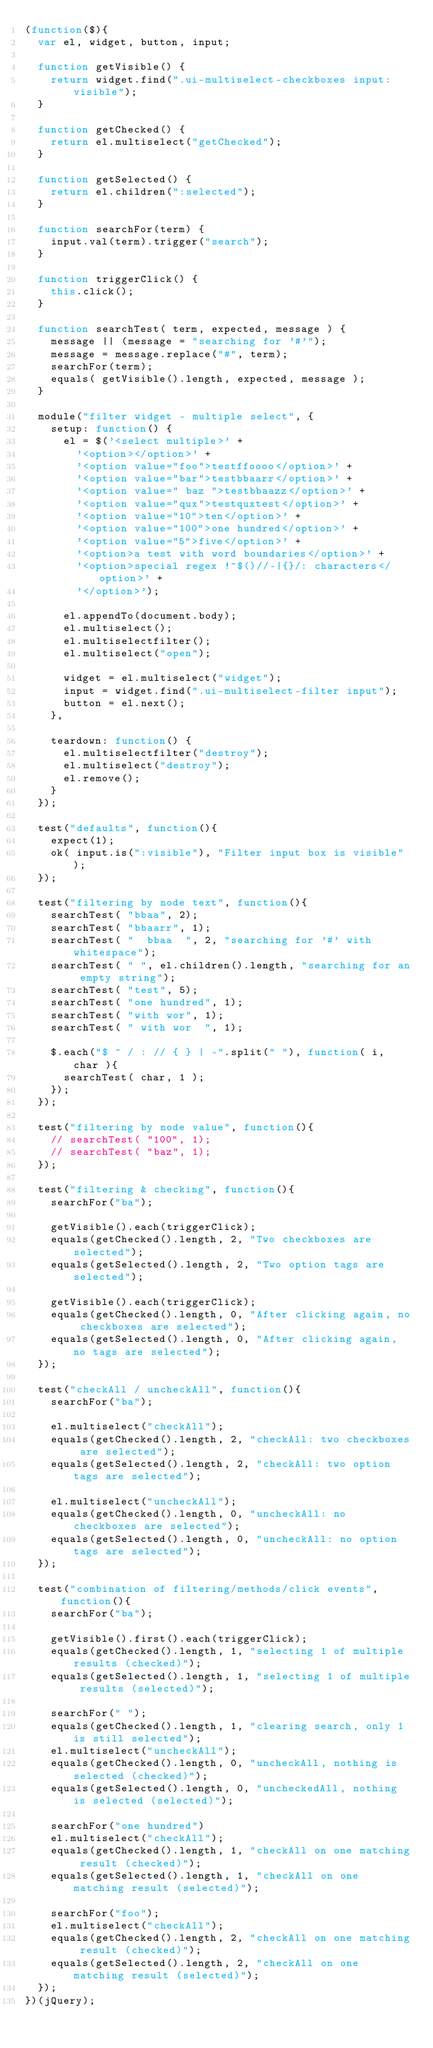<code> <loc_0><loc_0><loc_500><loc_500><_JavaScript_>(function($){
  var el, widget, button, input;

  function getVisible() {
    return widget.find(".ui-multiselect-checkboxes input:visible");
  }

  function getChecked() {
    return el.multiselect("getChecked");
  }

  function getSelected() {
    return el.children(":selected");
  }

  function searchFor(term) {
    input.val(term).trigger("search");
  }

  function triggerClick() {
    this.click();
  }

  function searchTest( term, expected, message ) {
    message || (message = "searching for '#'");
    message = message.replace("#", term);
    searchFor(term);
    equals( getVisible().length, expected, message );
  }

  module("filter widget - multiple select", {
    setup: function() {
      el = $('<select multiple>' +
        '<option></option>' +
        '<option value="foo">testffoooo</option>' +
        '<option value="bar">testbbaarr</option>' +
        '<option value=" baz ">testbbaazz</option>' +
        '<option value="qux">testquxtest</option>' +
        '<option value="10">ten</option>' +
        '<option value="100">one hundred</option>' +
        '<option value="5">five</option>' +
        '<option>a test with word boundaries</option>' +
        '<option>special regex !^$()//-|{}/: characters</option>' +
        '</option>');

      el.appendTo(document.body);
      el.multiselect();
      el.multiselectfilter();
      el.multiselect("open");

      widget = el.multiselect("widget");
      input = widget.find(".ui-multiselect-filter input");
      button = el.next();
    },

    teardown: function() {
      el.multiselectfilter("destroy");
      el.multiselect("destroy");
      el.remove();
    }
  });

  test("defaults", function(){
    expect(1);
    ok( input.is(":visible"), "Filter input box is visible" );
  });

  test("filtering by node text", function(){
    searchTest( "bbaa", 2);
    searchTest( "bbaarr", 1);
    searchTest( "  bbaa  ", 2, "searching for '#' with whitespace");
    searchTest( " ", el.children().length, "searching for an empty string");
    searchTest( "test", 5);
    searchTest( "one hundred", 1);
    searchTest( "with wor", 1);
    searchTest( " with wor  ", 1);

    $.each("$ ^ / : // { } | -".split(" "), function( i, char ){
      searchTest( char, 1 );
    });
  });

  test("filtering by node value", function(){
    // searchTest( "100", 1);
    // searchTest( "baz", 1);
  });

  test("filtering & checking", function(){
    searchFor("ba");

    getVisible().each(triggerClick);
    equals(getChecked().length, 2, "Two checkboxes are selected");
    equals(getSelected().length, 2, "Two option tags are selected");

    getVisible().each(triggerClick);
    equals(getChecked().length, 0, "After clicking again, no checkboxes are selected");
    equals(getSelected().length, 0, "After clicking again, no tags are selected");
  });

  test("checkAll / uncheckAll", function(){
    searchFor("ba");

    el.multiselect("checkAll");
    equals(getChecked().length, 2, "checkAll: two checkboxes are selected");
    equals(getSelected().length, 2, "checkAll: two option tags are selected");

    el.multiselect("uncheckAll");
    equals(getChecked().length, 0, "uncheckAll: no checkboxes are selected");
    equals(getSelected().length, 0, "uncheckAll: no option tags are selected");
  });

  test("combination of filtering/methods/click events", function(){
    searchFor("ba");

    getVisible().first().each(triggerClick);
    equals(getChecked().length, 1, "selecting 1 of multiple results (checked)");
    equals(getSelected().length, 1, "selecting 1 of multiple results (selected)");

    searchFor(" ");
    equals(getChecked().length, 1, "clearing search, only 1 is still selected");
    el.multiselect("uncheckAll");
    equals(getChecked().length, 0, "uncheckAll, nothing is selected (checked)");
    equals(getSelected().length, 0, "uncheckedAll, nothing is selected (selected)");

    searchFor("one hundred")
    el.multiselect("checkAll");
    equals(getChecked().length, 1, "checkAll on one matching result (checked)");
    equals(getSelected().length, 1, "checkAll on one matching result (selected)");

    searchFor("foo");
    el.multiselect("checkAll");
    equals(getChecked().length, 2, "checkAll on one matching result (checked)");
    equals(getSelected().length, 2, "checkAll on one matching result (selected)");
  });
})(jQuery);
</code> 